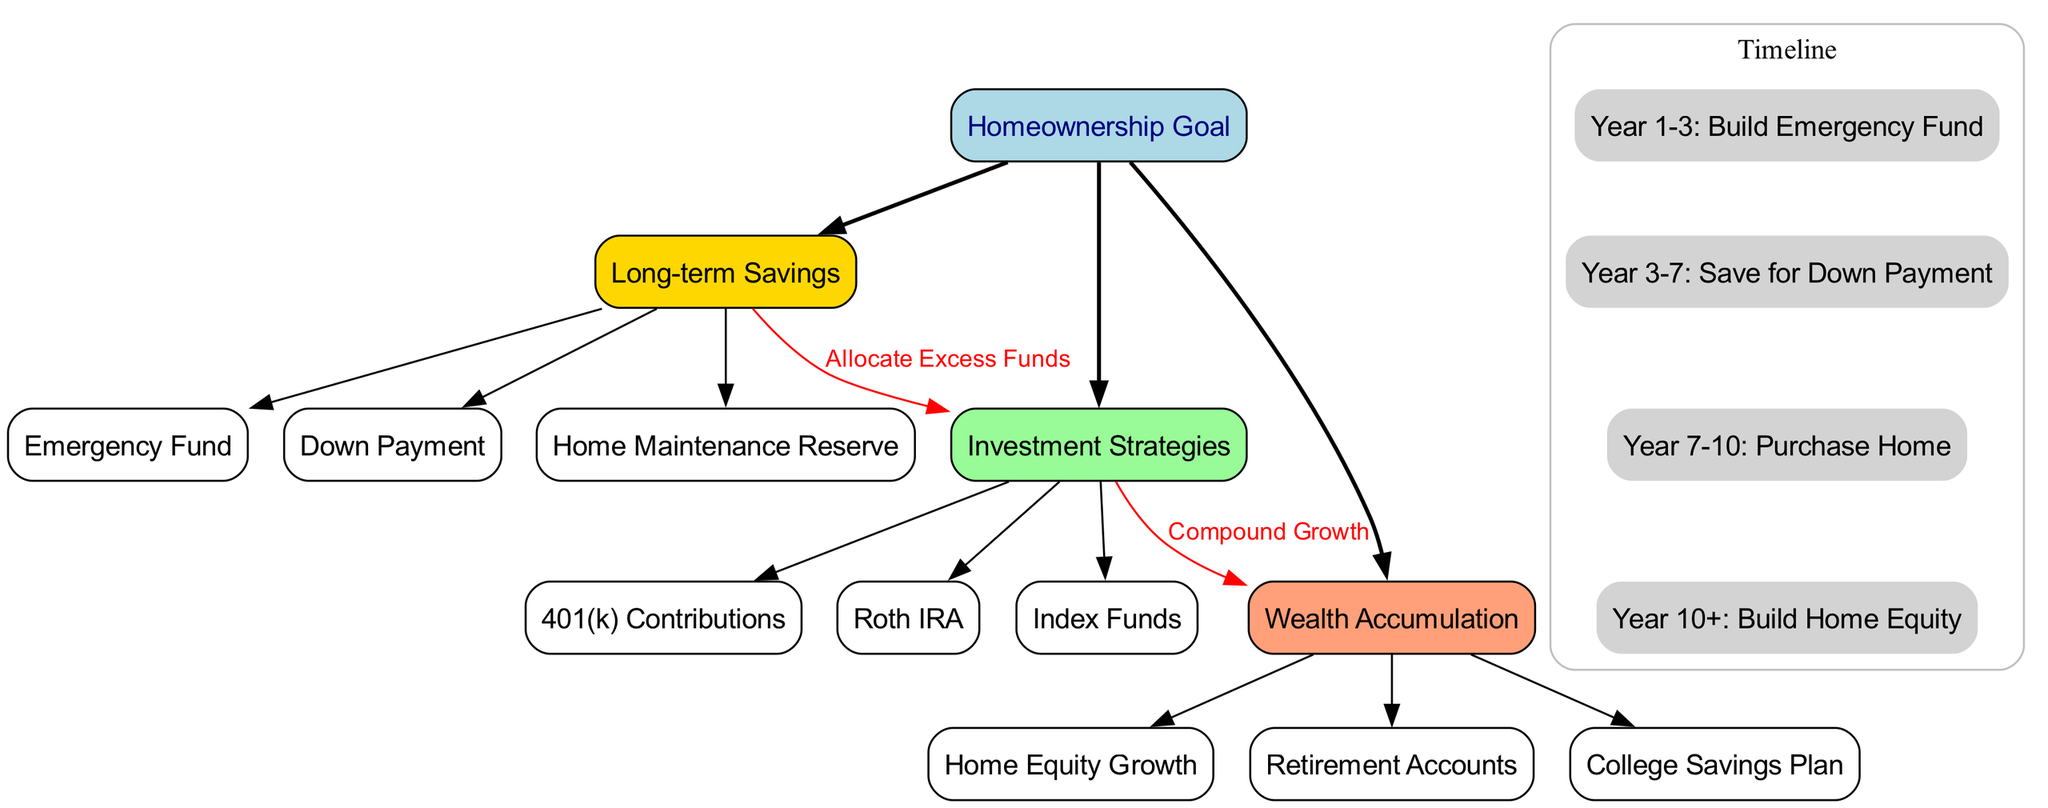What is the central node of the diagram? The central node is clearly labeled as "Homeownership Goal" in the diagram, making it simple to identify.
Answer: Homeownership Goal How many main branches does the diagram have? There are three main branches identified in the diagram: "Long-term Savings," "Investment Strategies," and "Wealth Accumulation." This is evident from the layout of the nodes extending from the central node.
Answer: 3 What are the three subnodes under "Long-term Savings"? The subnodes under "Long-term Savings" can be found by looking directly beneath that branch's label, which lists "Emergency Fund," "Down Payment," and "Home Maintenance Reserve."
Answer: Emergency Fund, Down Payment, Home Maintenance Reserve What does the label on the connection from "Long-term Savings" to "Investment Strategies" say? The diagram includes a labeled edge between "Long-term Savings" and "Investment Strategies," and the label specifically states "Allocate Excess Funds." This is a key detail in understanding the relationship between these branches.
Answer: Allocate Excess Funds What is the timeline duration for saving for a down payment? By examining the timeline section of the diagram, it indicates that saving for a down payment takes place during "Year 3-7," representing a total of 4 years.
Answer: Year 3-7 Which investment strategy contributes to wealth accumulation? The diagram shows a direct relationship between "Investment Strategies" and "Wealth Accumulation." Notably, each subnode under "Investment Strategies," such as "401(k) Contributions," "Roth IRA," and "Index Funds," is designed to promote wealth accumulation, but all flow toward "Wealth Accumulation."
Answer: Compound Growth What do the nodes under "Wealth Accumulation" represent? The nodes under "Wealth Accumulation" explicitly represent different facets of wealth that can grow over time, including "Home Equity Growth," "Retirement Accounts," and "College Savings Plan." Each indicates a specific area of accumulating wealth related to the homeownership goal.
Answer: Home Equity Growth, Retirement Accounts, College Savings Plan What is the color scheme of the main branches in the diagram? The colors for the main branches are distinct: "Long-term Savings" is Gold, "Investment Strategies" is Pale Green, and "Wealth Accumulation" is Light Salmon. This color coding helps visually differentiate the categories in the diagram.
Answer: Gold, Pale Green, Light Salmon 